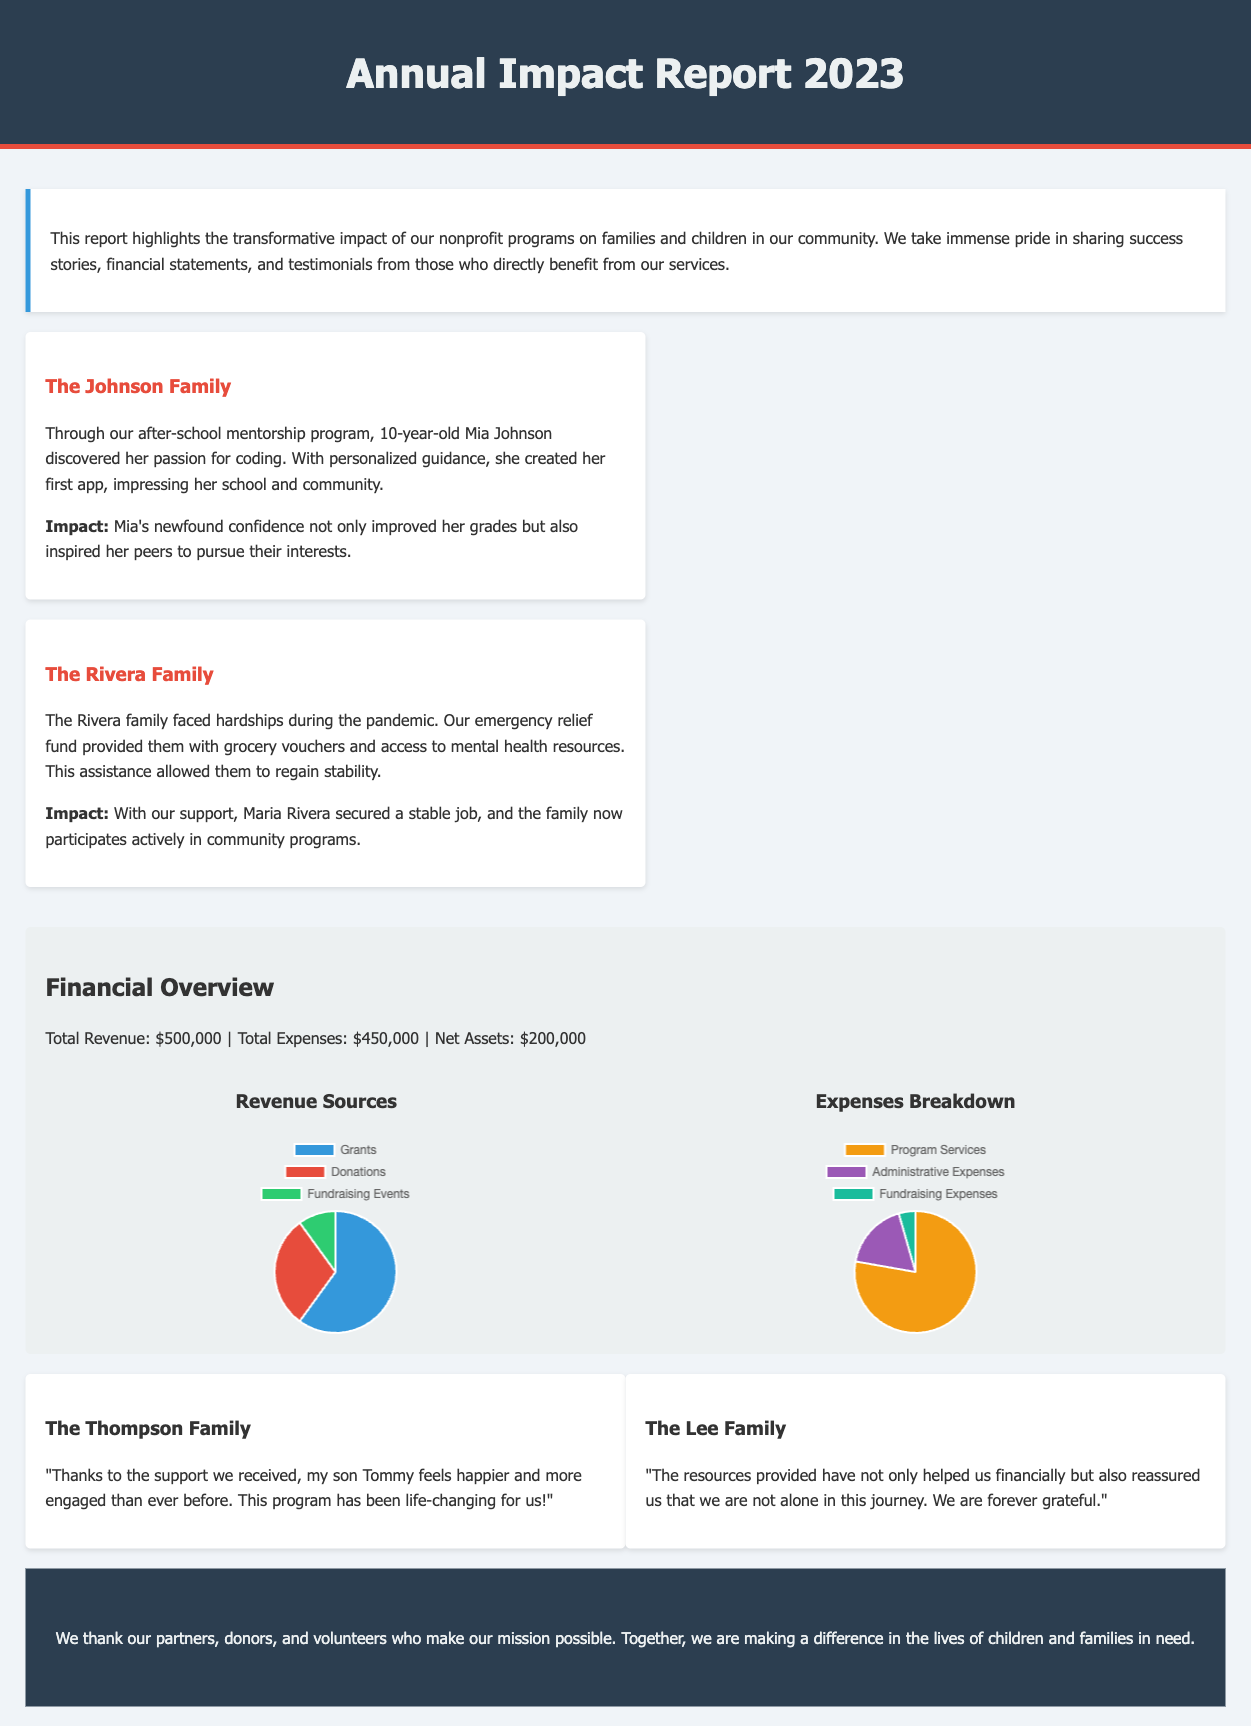what is the total revenue? The total revenue listed in the financial overview is $500,000.
Answer: $500,000 who is highlighted in the first success story? The first success story features the Johnson Family focusing on Mia Johnson.
Answer: Johnson Family what did Mia Johnson create? Mia Johnson created her first app through the after-school mentorship program.
Answer: her first app how much were the total expenses? The total expenses mentioned in the financial overview are $450,000.
Answer: $450,000 what is one key impact of the Rivera family's experience? The Rivera family's experience led to Maria Rivera securing a stable job.
Answer: securing a stable job how many testimonials are included in the report? There are two testimonials included in the report, from the Thompson and Lee families.
Answer: two what is the color code for donations in the revenue chart? The color code for donations in the revenue chart is red.
Answer: red which program helped Tommy Thompson feel happier? The program that helped Tommy Thompson feel happier is not explicitly named but referred to as "the support we received."
Answer: the support we received what year does the impact report cover? The impact report covers the year 2023.
Answer: 2023 